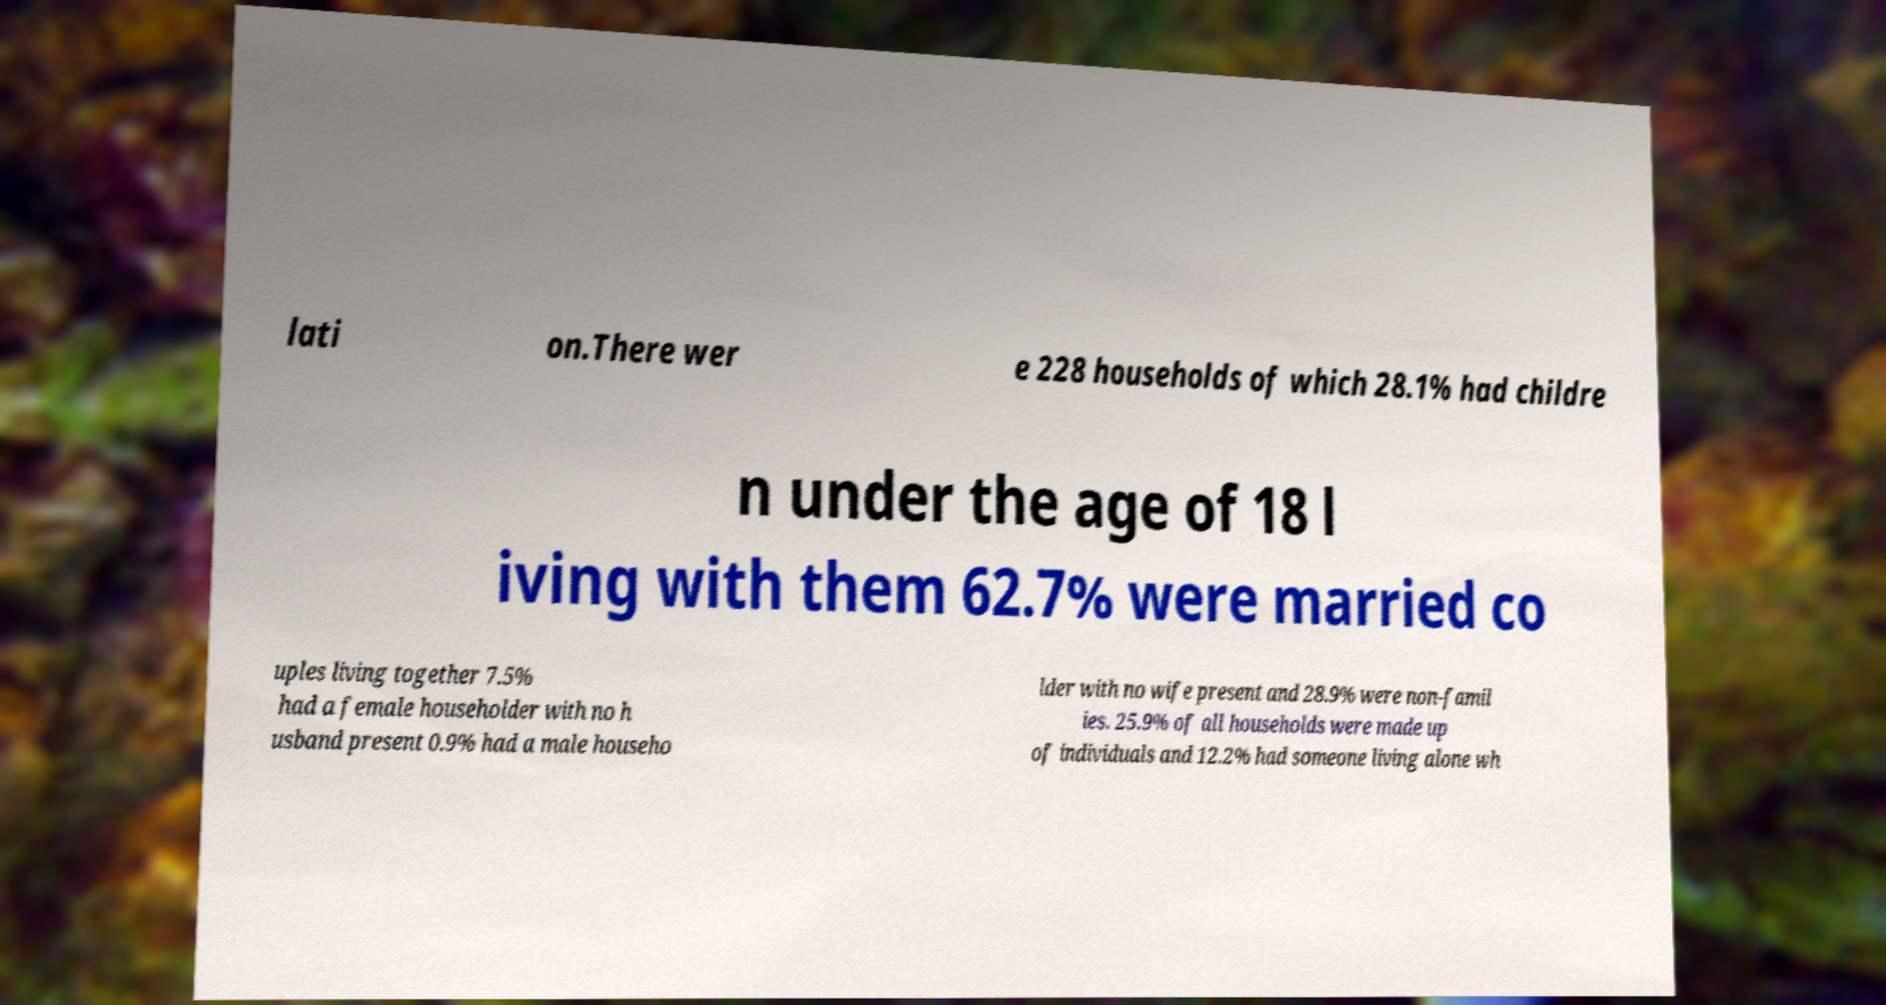Can you accurately transcribe the text from the provided image for me? lati on.There wer e 228 households of which 28.1% had childre n under the age of 18 l iving with them 62.7% were married co uples living together 7.5% had a female householder with no h usband present 0.9% had a male househo lder with no wife present and 28.9% were non-famil ies. 25.9% of all households were made up of individuals and 12.2% had someone living alone wh 